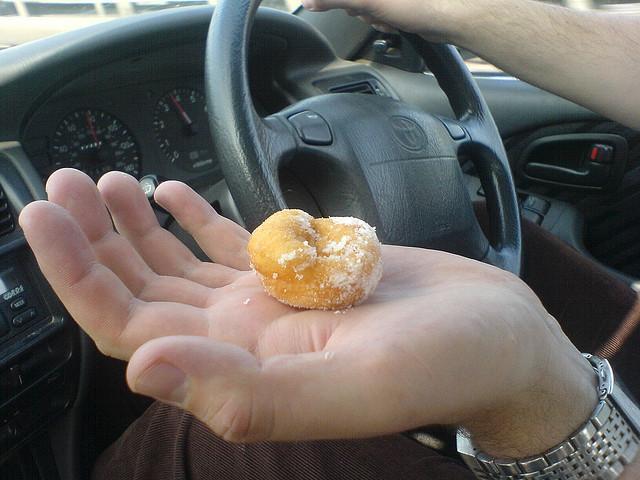Is the statement "The donut is touching the person." accurate regarding the image?
Answer yes or no. Yes. 